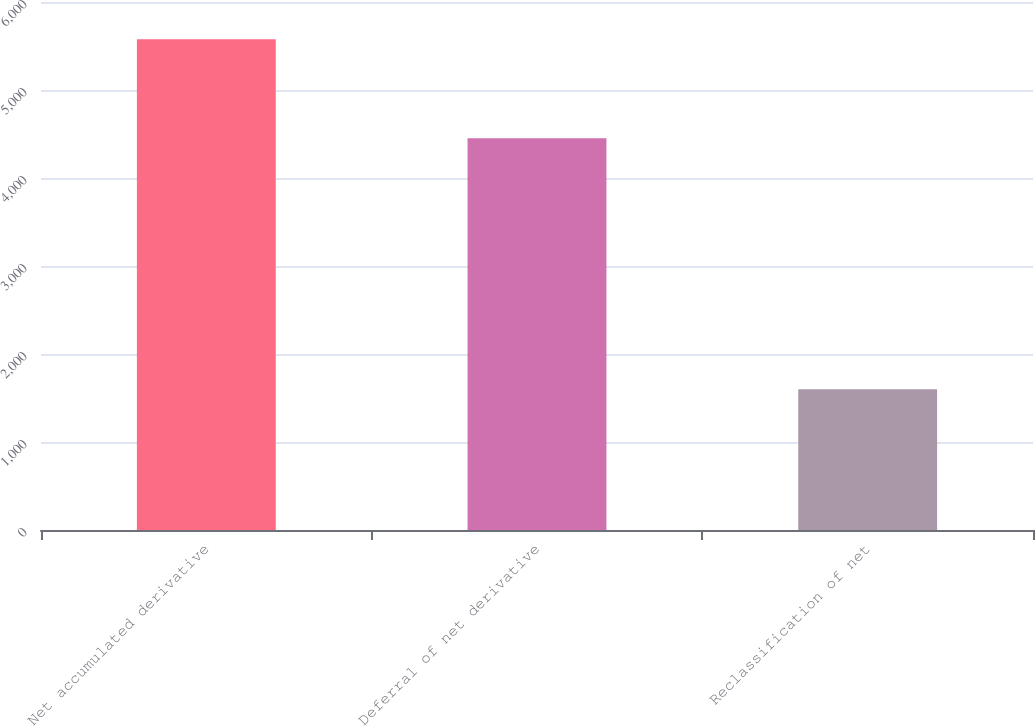Convert chart to OTSL. <chart><loc_0><loc_0><loc_500><loc_500><bar_chart><fcel>Net accumulated derivative<fcel>Deferral of net derivative<fcel>Reclassification of net<nl><fcel>5576<fcel>4452<fcel>1599<nl></chart> 